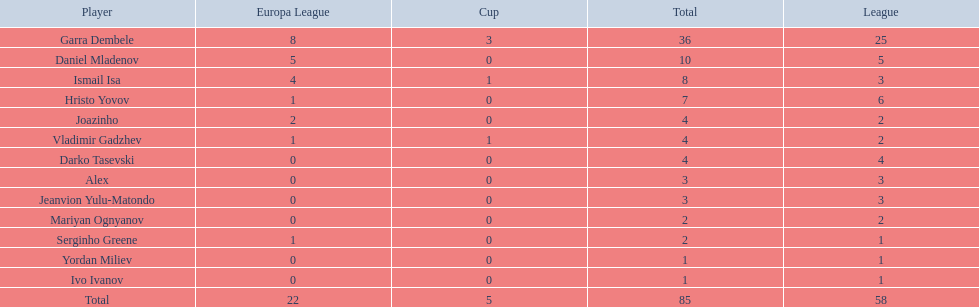What players did not score in all 3 competitions? Daniel Mladenov, Hristo Yovov, Joazinho, Darko Tasevski, Alex, Jeanvion Yulu-Matondo, Mariyan Ognyanov, Serginho Greene, Yordan Miliev, Ivo Ivanov. Which of those did not have total more then 5? Darko Tasevski, Alex, Jeanvion Yulu-Matondo, Mariyan Ognyanov, Serginho Greene, Yordan Miliev, Ivo Ivanov. Which ones scored more then 1 total? Darko Tasevski, Alex, Jeanvion Yulu-Matondo, Mariyan Ognyanov. Which of these player had the lease league points? Mariyan Ognyanov. 